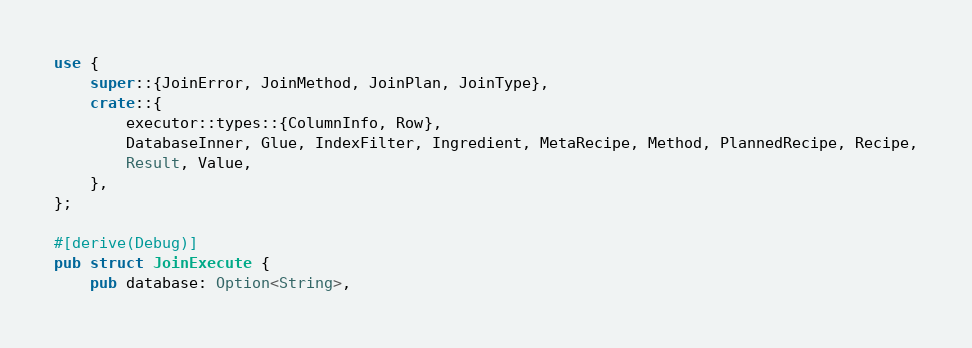<code> <loc_0><loc_0><loc_500><loc_500><_Rust_>use {
	super::{JoinError, JoinMethod, JoinPlan, JoinType},
	crate::{
		executor::types::{ColumnInfo, Row},
		DatabaseInner, Glue, IndexFilter, Ingredient, MetaRecipe, Method, PlannedRecipe, Recipe,
		Result, Value,
	},
};

#[derive(Debug)]
pub struct JoinExecute {
	pub database: Option<String>,</code> 